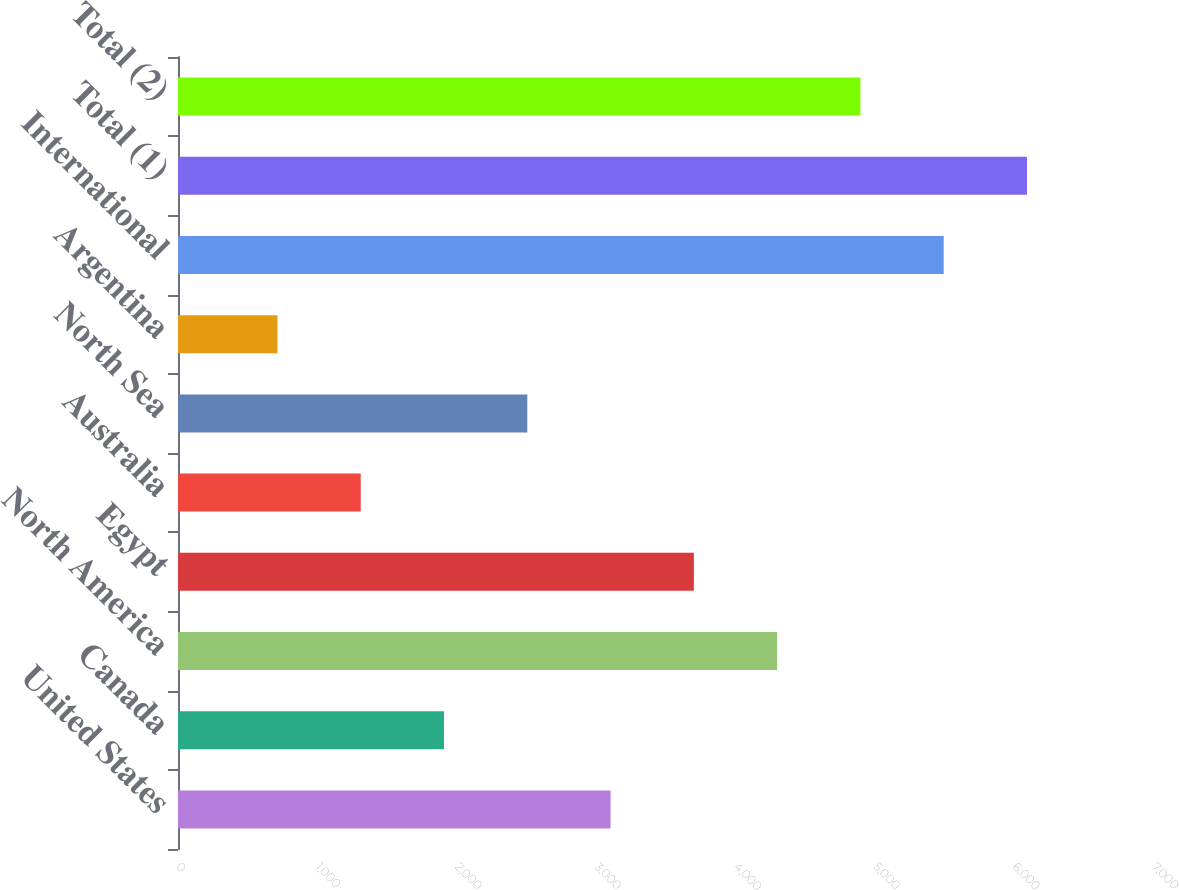Convert chart to OTSL. <chart><loc_0><loc_0><loc_500><loc_500><bar_chart><fcel>United States<fcel>Canada<fcel>North America<fcel>Egypt<fcel>Australia<fcel>North Sea<fcel>Argentina<fcel>International<fcel>Total (1)<fcel>Total (2)<nl><fcel>3102.5<fcel>1907.9<fcel>4297.1<fcel>3699.8<fcel>1310.6<fcel>2505.2<fcel>713.3<fcel>5491.7<fcel>6089<fcel>4894.4<nl></chart> 